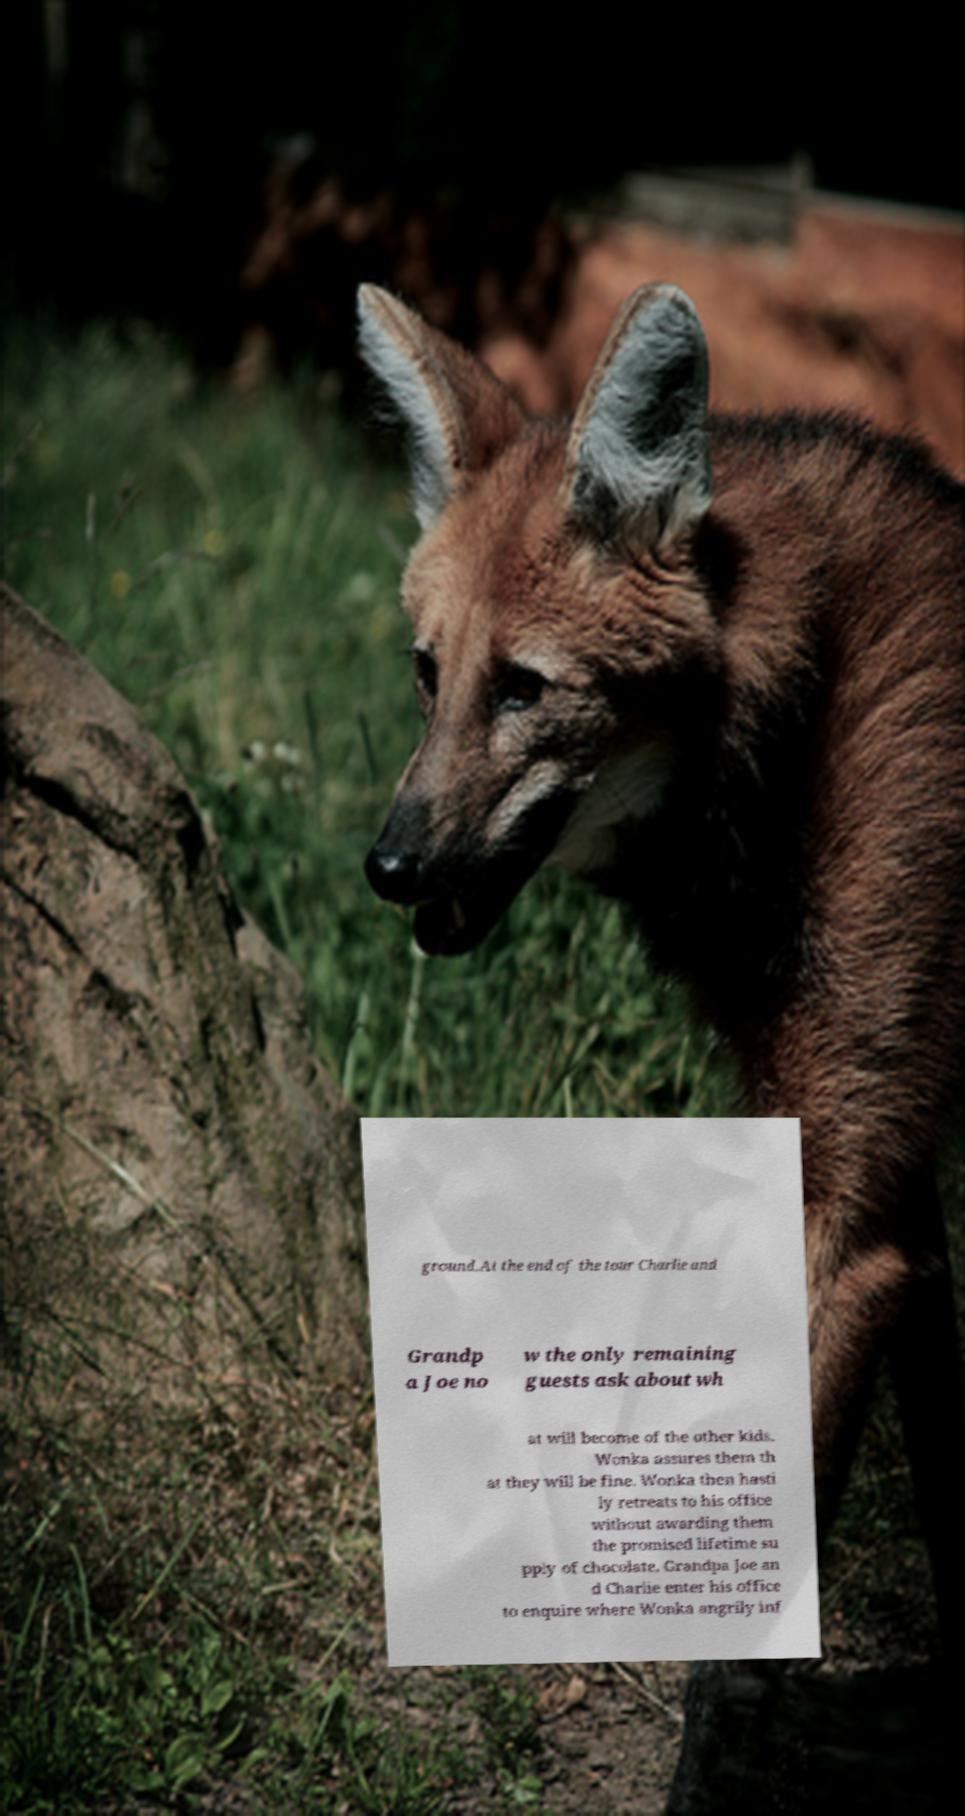What messages or text are displayed in this image? I need them in a readable, typed format. ground.At the end of the tour Charlie and Grandp a Joe no w the only remaining guests ask about wh at will become of the other kids. Wonka assures them th at they will be fine. Wonka then hasti ly retreats to his office without awarding them the promised lifetime su pply of chocolate. Grandpa Joe an d Charlie enter his office to enquire where Wonka angrily inf 